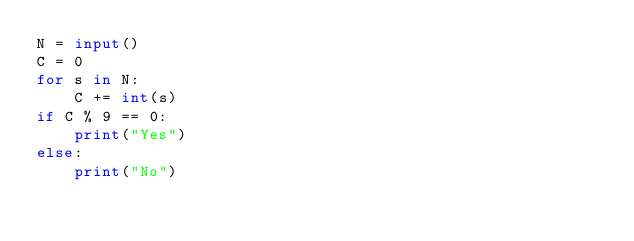<code> <loc_0><loc_0><loc_500><loc_500><_Python_>N = input()
C = 0
for s in N:
    C += int(s)
if C % 9 == 0:
    print("Yes")
else:
    print("No")</code> 